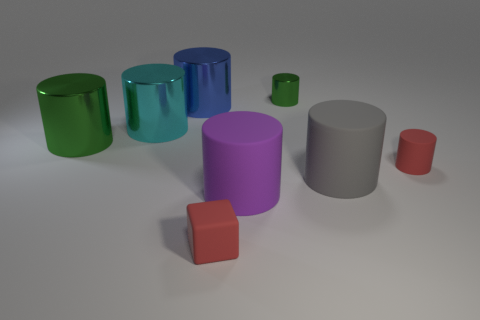Is there a small cylinder made of the same material as the gray object?
Keep it short and to the point. Yes. There is a tiny matte thing to the left of the green object that is behind the green cylinder that is in front of the cyan metal thing; what shape is it?
Make the answer very short. Cube. Is the color of the tiny matte cylinder to the right of the blue thing the same as the rubber object in front of the large purple rubber cylinder?
Offer a very short reply. Yes. Is there any other thing that is the same size as the purple cylinder?
Your answer should be very brief. Yes. Are there any tiny blocks behind the big cyan shiny cylinder?
Give a very brief answer. No. How many large cyan things are the same shape as the tiny green metallic thing?
Give a very brief answer. 1. What color is the tiny rubber object that is to the left of the red thing that is to the right of the purple matte cylinder that is behind the cube?
Your answer should be very brief. Red. Do the cylinder in front of the gray matte thing and the big cylinder to the right of the purple rubber cylinder have the same material?
Your response must be concise. Yes. What number of objects are either green things left of the blue metal object or big objects?
Offer a very short reply. 5. How many things are either small yellow metal things or big gray matte objects that are right of the cyan object?
Give a very brief answer. 1. 